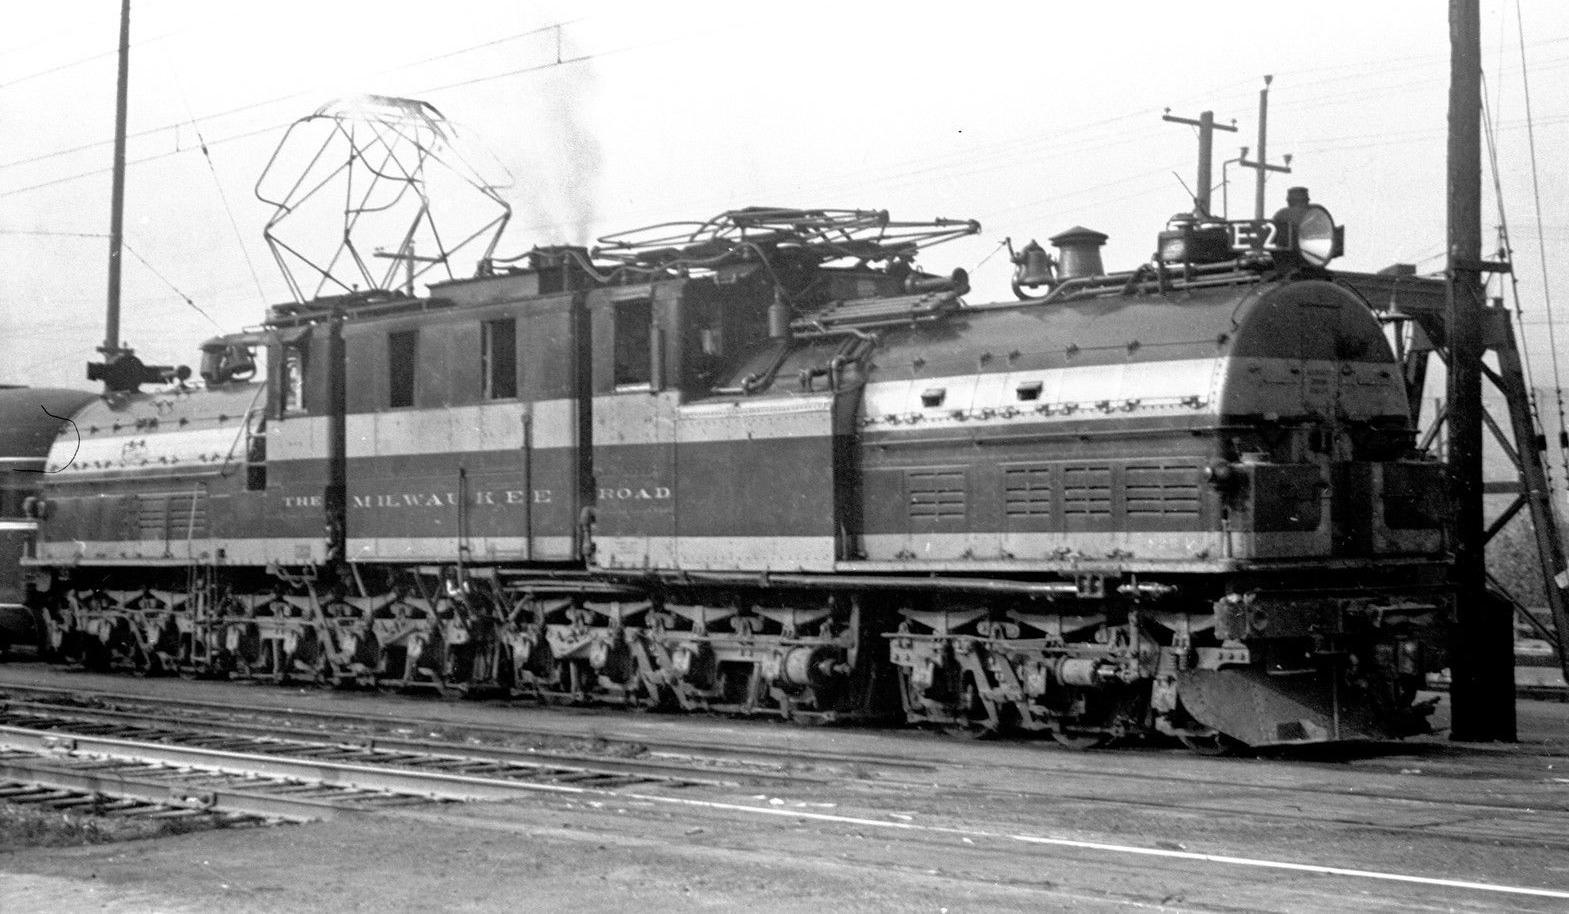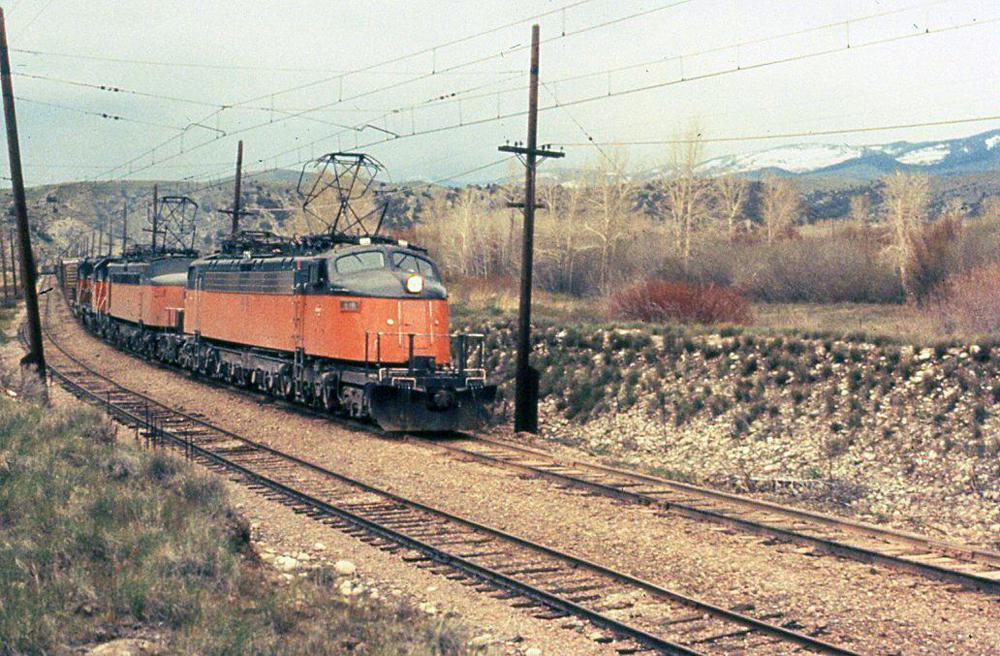The first image is the image on the left, the second image is the image on the right. For the images shown, is this caption "None of the trains are near a light pole." true? Answer yes or no. No. 